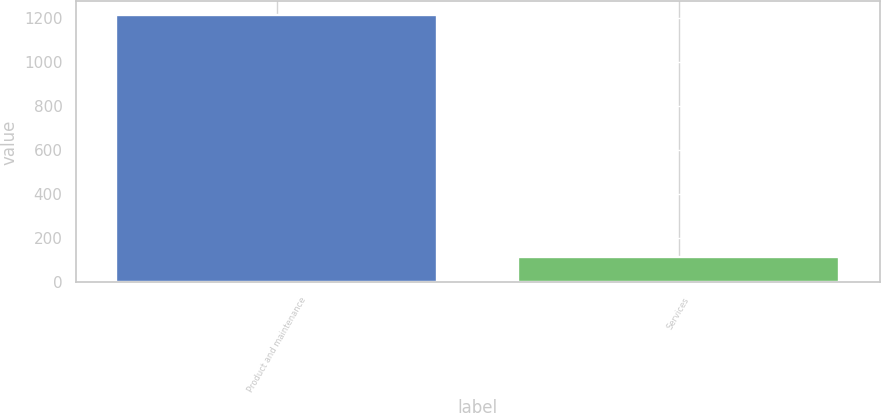Convert chart. <chart><loc_0><loc_0><loc_500><loc_500><bar_chart><fcel>Product and maintenance<fcel>Services<nl><fcel>1212.4<fcel>114<nl></chart> 